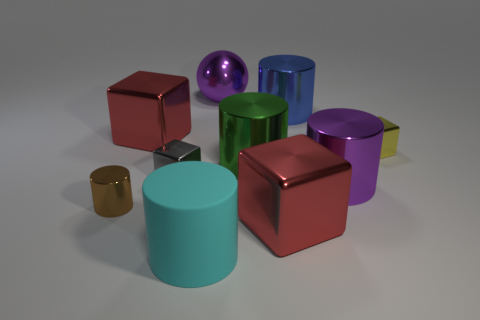Subtract 1 cylinders. How many cylinders are left? 4 Subtract all purple cylinders. How many cylinders are left? 4 Subtract all balls. How many objects are left? 9 Add 4 purple metallic cylinders. How many purple metallic cylinders are left? 5 Add 6 spheres. How many spheres exist? 7 Subtract 1 brown cylinders. How many objects are left? 9 Subtract all red objects. Subtract all red objects. How many objects are left? 6 